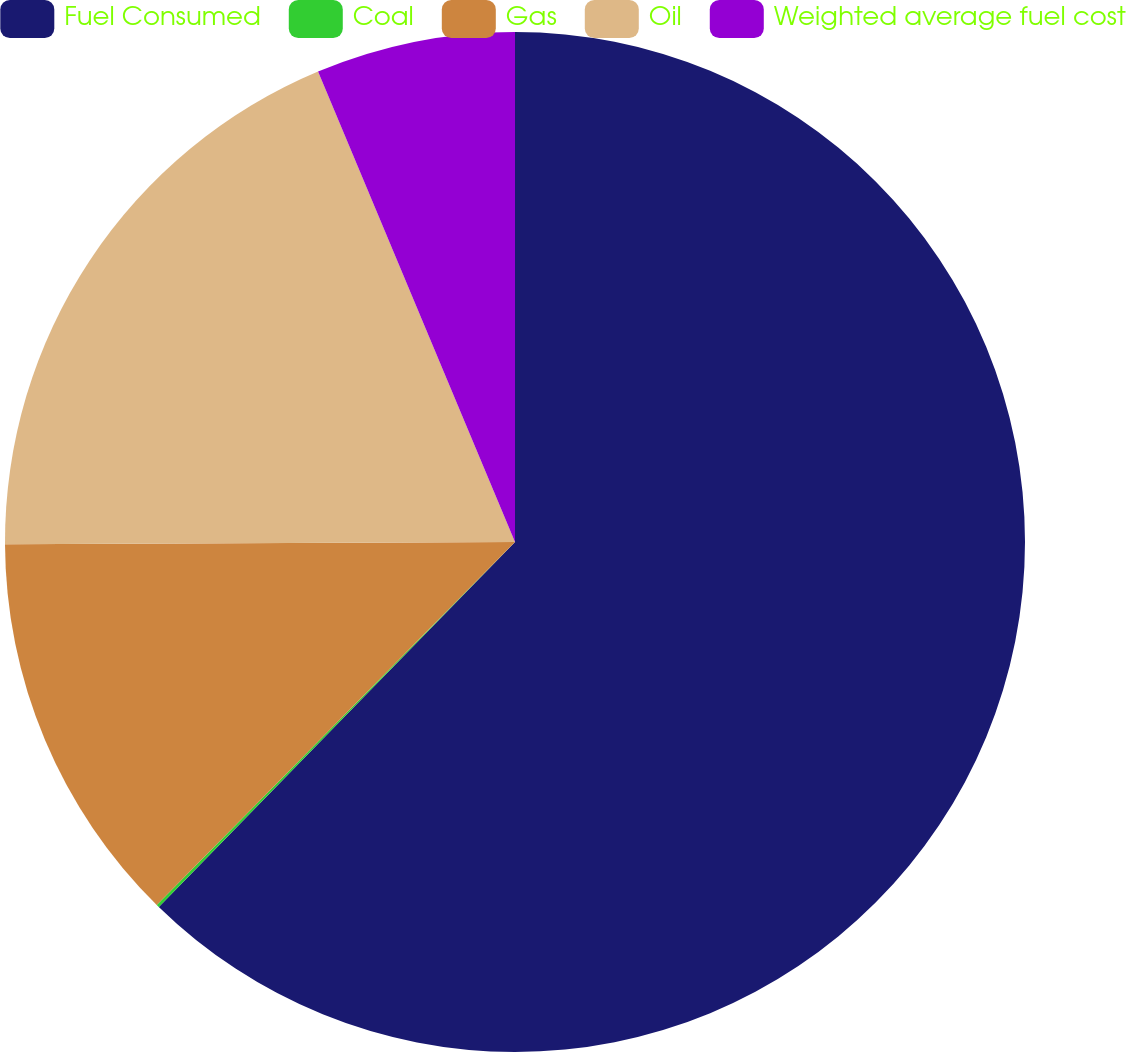<chart> <loc_0><loc_0><loc_500><loc_500><pie_chart><fcel>Fuel Consumed<fcel>Coal<fcel>Gas<fcel>Oil<fcel>Weighted average fuel cost<nl><fcel>62.3%<fcel>0.09%<fcel>12.53%<fcel>18.76%<fcel>6.31%<nl></chart> 